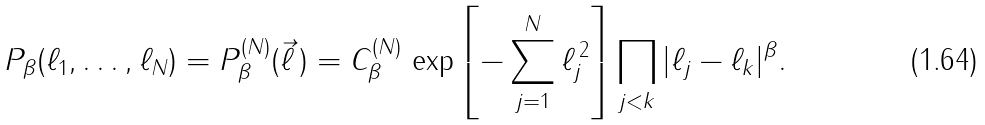Convert formula to latex. <formula><loc_0><loc_0><loc_500><loc_500>P _ { \beta } ( \ell _ { 1 } , \dots , \ell _ { N } ) = P _ { \beta } ^ { ( N ) } ( \vec { \ell } \, ) = C _ { \beta } ^ { ( N ) } \, \exp \left [ - \sum _ { j = 1 } ^ { N } \ell _ { j } ^ { \, 2 } \right ] \prod _ { j < k } | \ell _ { j } - \ell _ { k } | ^ { \beta } .</formula> 